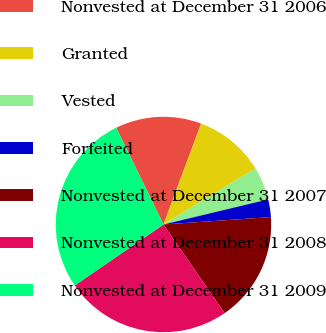Convert chart. <chart><loc_0><loc_0><loc_500><loc_500><pie_chart><fcel>Nonvested at December 31 2006<fcel>Granted<fcel>Vested<fcel>Forfeited<fcel>Nonvested at December 31 2007<fcel>Nonvested at December 31 2008<fcel>Nonvested at December 31 2009<nl><fcel>12.92%<fcel>10.6%<fcel>4.97%<fcel>2.65%<fcel>16.49%<fcel>25.02%<fcel>27.35%<nl></chart> 